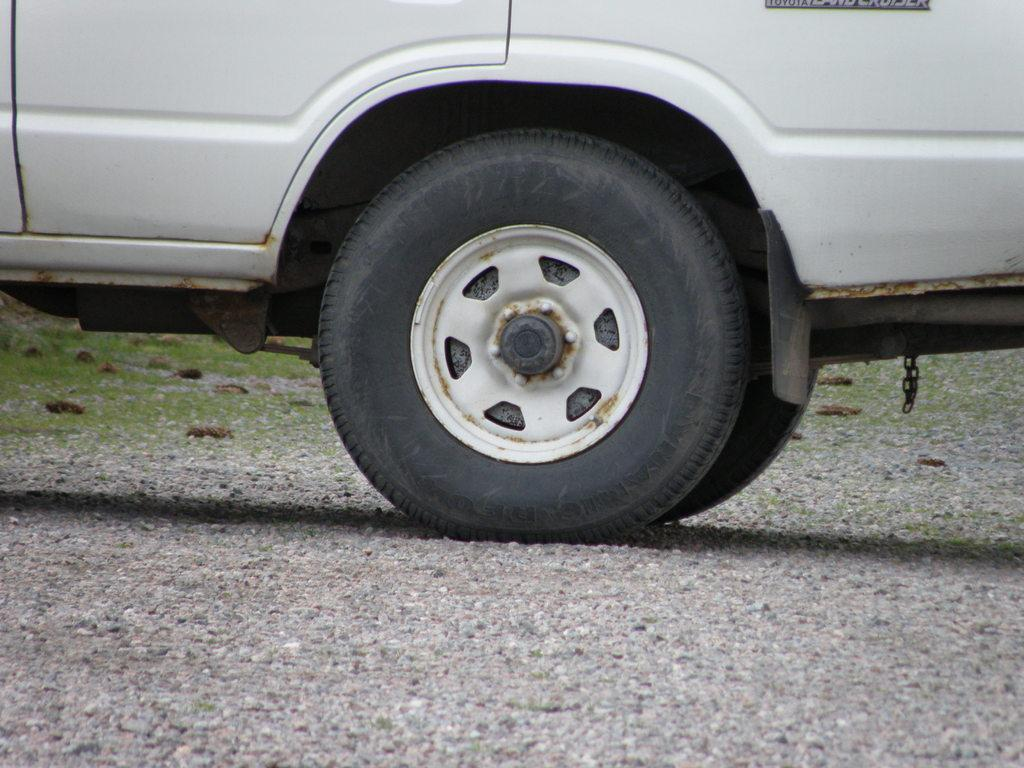What type of vehicle is in the image? The facts do not specify the type of vehicle, but it is mentioned that the vehicle has tires and is on land. What can be seen on the ground in the image? There are rocks and grass in the image. How many tires does the vehicle have? The vehicle has tires, but the exact number is not specified. What type of disease is affecting the vehicle in the image? There is no indication of a disease affecting the vehicle in the image. How does the vehicle blow air in the image? The vehicle does not blow air in the image; it is stationary. 